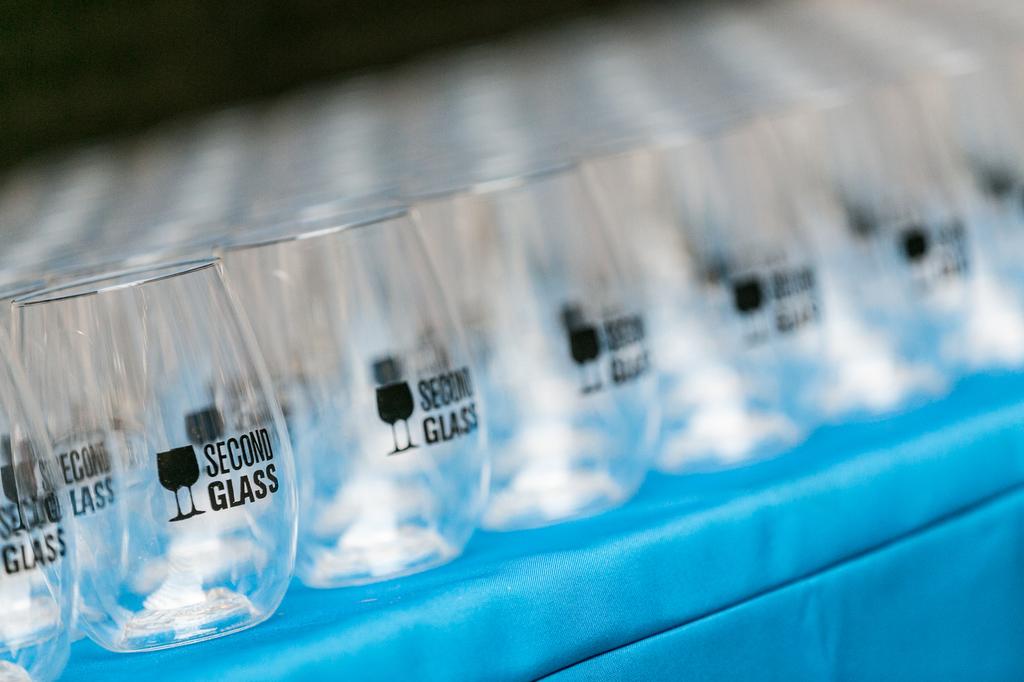Is this the first or second glass?
Your answer should be compact. Second. 